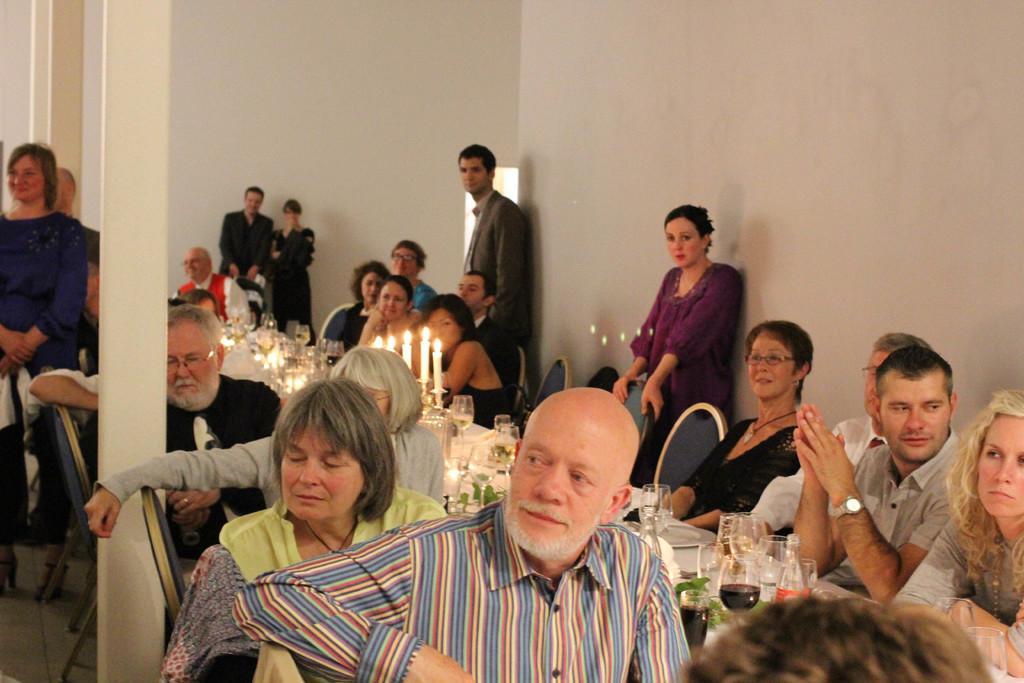Could you give a brief overview of what you see in this image? In this image, we can see persons wearing clothes and sitting on chairs in front of the table. This table contains glasses, bottles and candles. There are some persons standing and wearing clothes. There are pillars on the left side of the image. In the background, we can see a wall. 